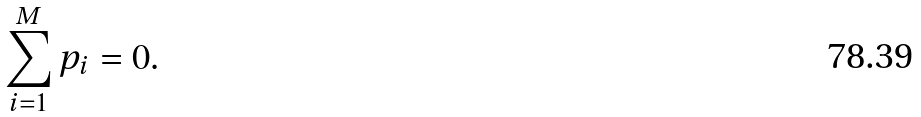Convert formula to latex. <formula><loc_0><loc_0><loc_500><loc_500>\sum _ { i = 1 } ^ { M } p _ { i } = 0 .</formula> 